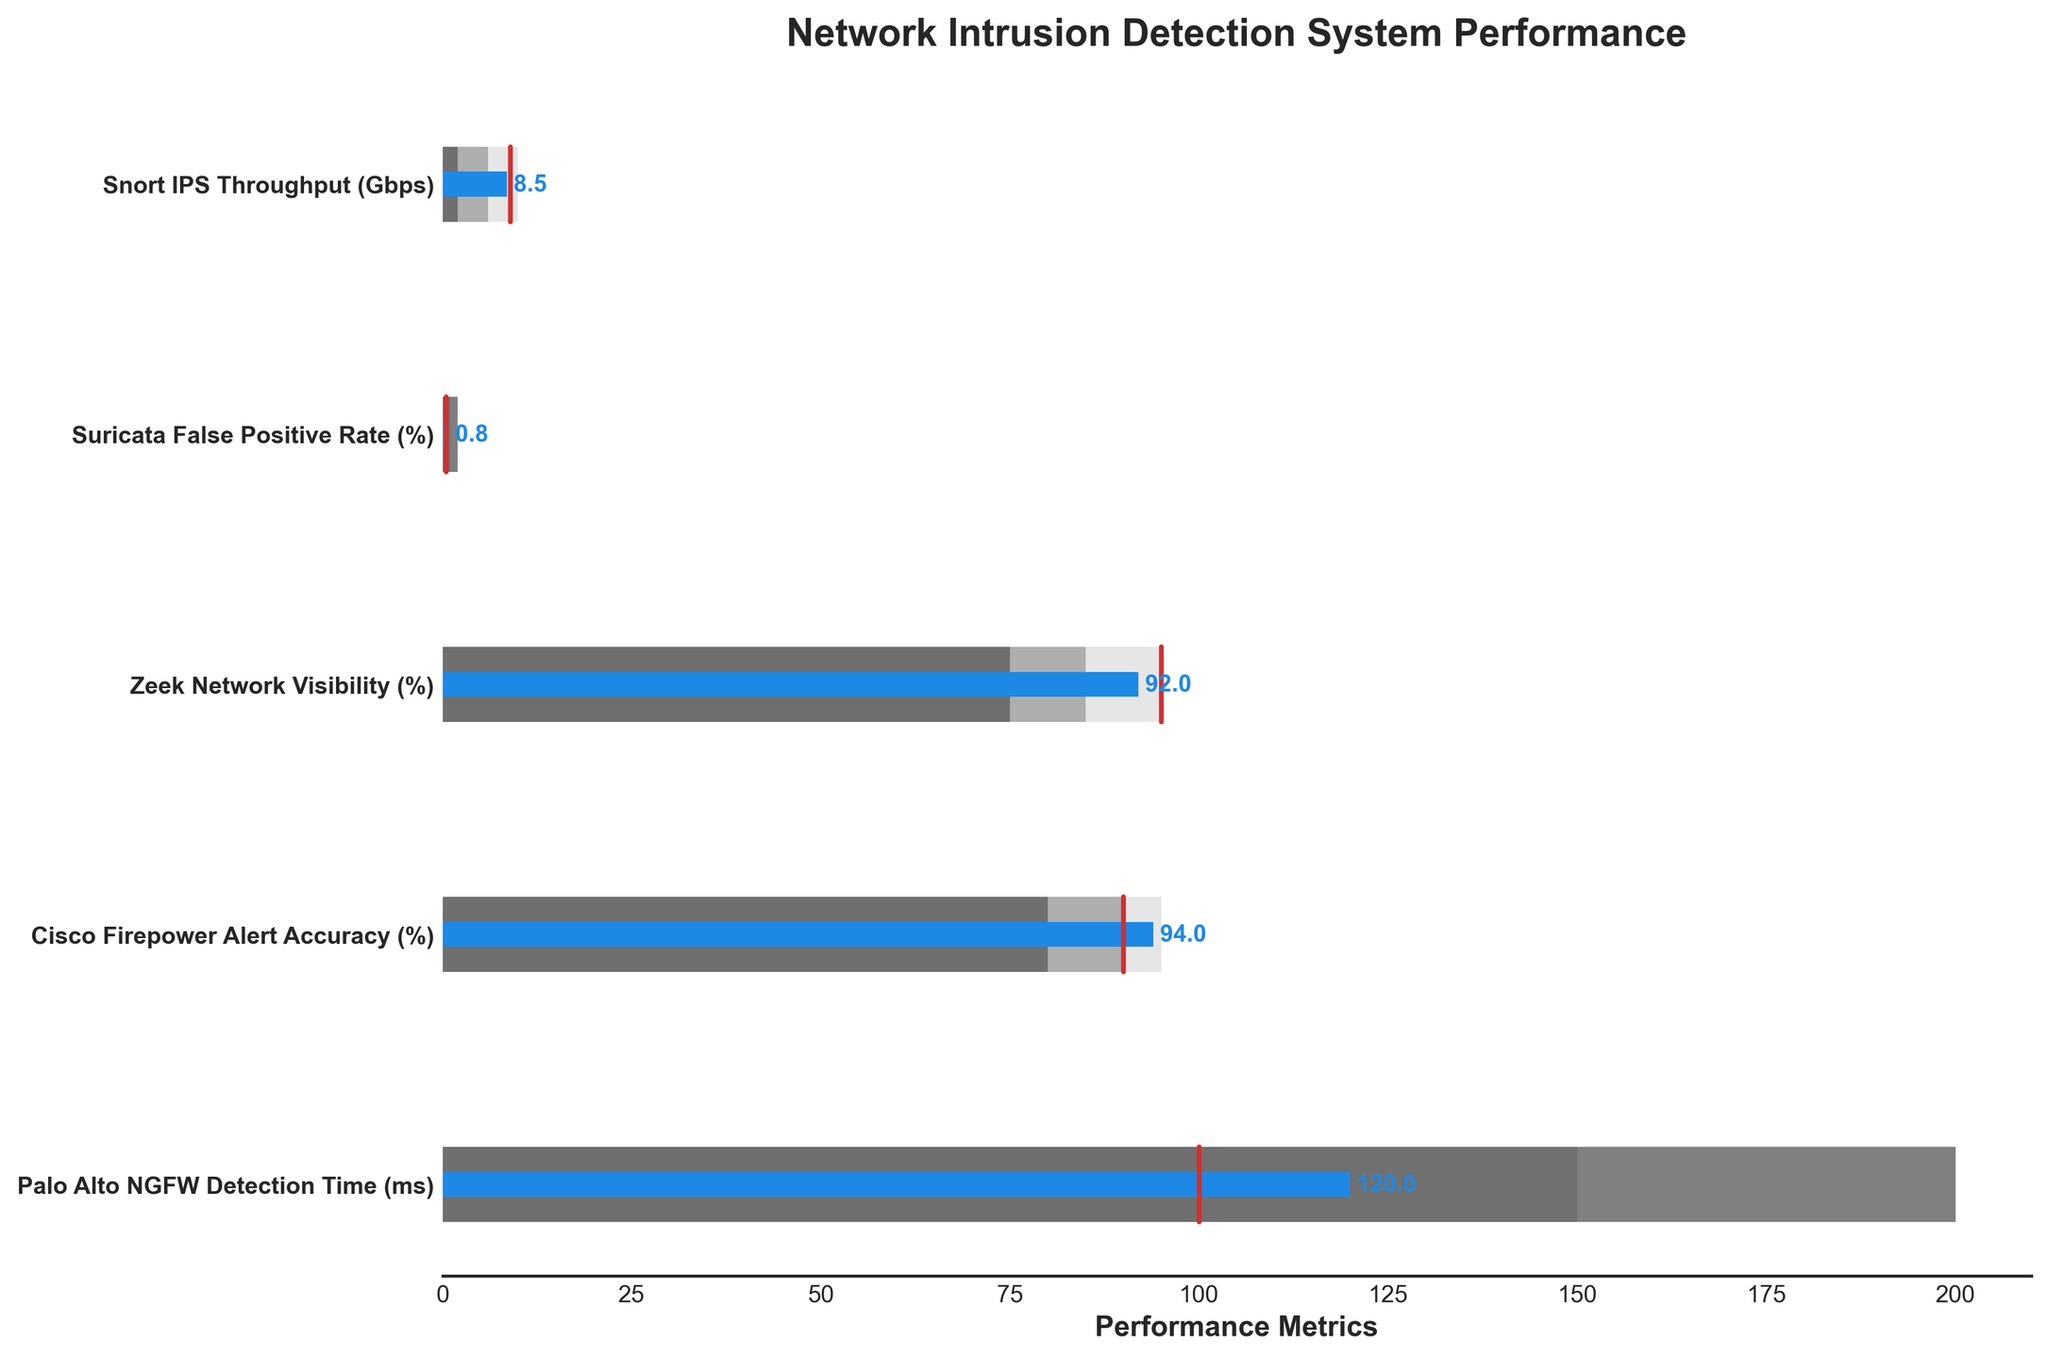What is the actual throughput (in Gbps) for Snort IPS compared to its benchmark? The actual throughput for Snort IPS is 8.5 Gbps, and the benchmark is 9 Gbps. This can be seen in the figure where the blue bar representing the actual value reaches 8.5 on the x-axis, while the red line indicating the benchmark is at 9.
Answer: 8.5 Gbps vs. 9 Gbps How does Suricata's False Positive Rate (%), actual performance compare to its benchmark? Suricata's actual False Positive Rate is 0.8%, while the benchmark is 0.5%. This is observed by looking at the position of the blue bar and the red benchmark line on the x-axis.
Answer: 0.8% vs. 0.5% Which metric has the largest difference between actual and benchmark values? The metric with the largest difference between actual and benchmark values is "Palo Alto NGFW Detection Time (ms)," with an actual value of 120 ms compared to a benchmark of 100 ms, a difference of 20 ms.
Answer: Palo Alto NGFW Detection Time (ms) What is the actual performance for the Cisco Firepower Alert Accuracy (%)? The actual performance for Cisco Firepower Alert Accuracy is 94%. The blue bar representing the actual value is positioned at 94% on the x-axis.
Answer: 94% Compare the actual and benchmark value for Zeek Network Visibility (%). The actual value for Zeek Network Visibility is 92%, while the benchmark is 95%. This comparison is derived from the blue bar for the actual value and the red benchmark line.
Answer: 92% vs. 95% What is the performance range for the Suricata False Positive Rate (%) from worst to best? The performance range for Suricata False Positive Rate is from 2% (worst) to 0.5% (best), as shown by the three different shaded areas in the bullet chart.
Answer: 2% to 0.5% How does the actual detection time of Palo Alto NGFW compare within its range? The actual detection time of Palo Alto NGFW is 120 ms, which falls in the middle range between 150 ms and 100 ms. This is shown by the position of the blue bar and the different shaded areas.
Answer: Middle range (120 ms) Which system exceeds its benchmark value? "Cisco Firepower Alert Accuracy (%)" is the only system where the actual value (94%) exceeds the benchmark (90%).
Answer: Cisco Firepower Alert Accuracy Using the bullet chart, determine which system's actual performance is closest to its best range value. Zeek Network Visibility (%) actual performance at 92% is closest to its best range value of 95%, as indicated by the blue bar and the value ranges.
Answer: Zeek Network Visibility Is there any metric where the actual performance is below the worst range value? No, all actual performances fall within or above their respective worst range value based on the positions of the blue bars compared to the performance ranges.
Answer: No 